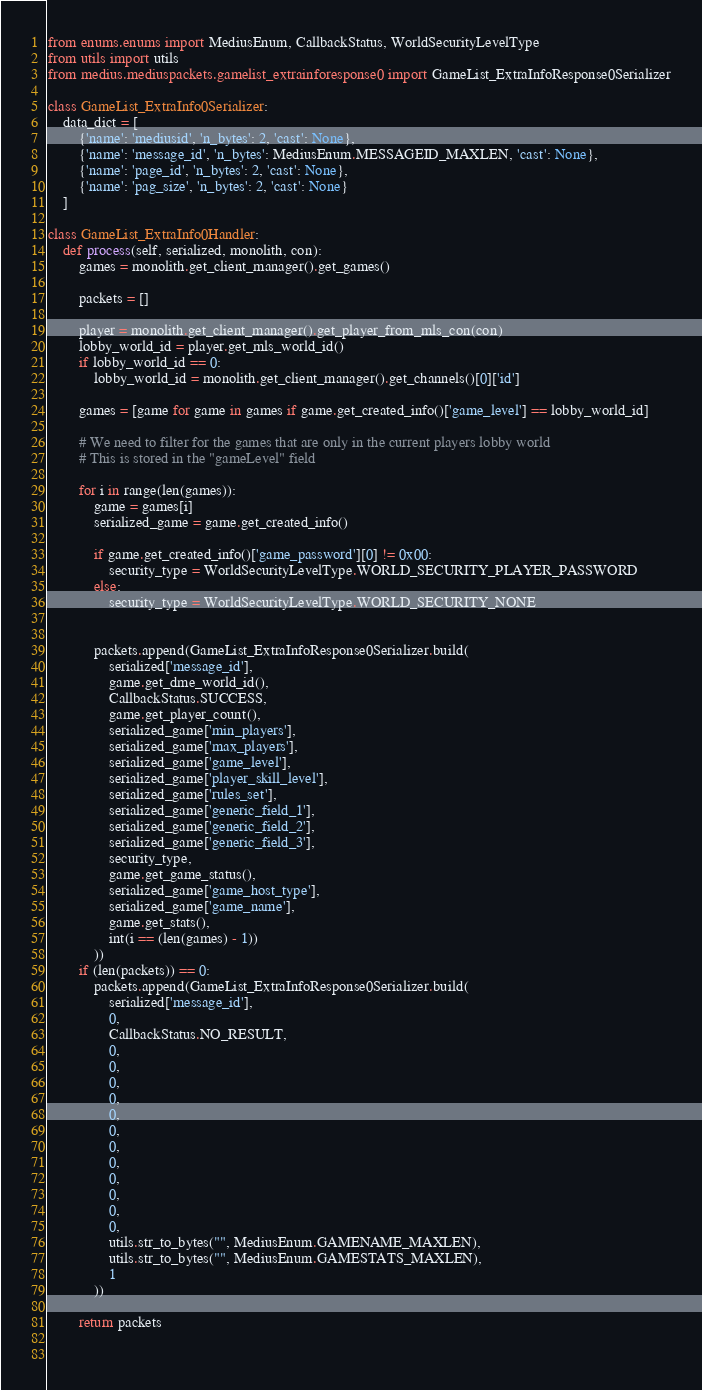Convert code to text. <code><loc_0><loc_0><loc_500><loc_500><_Python_>from enums.enums import MediusEnum, CallbackStatus, WorldSecurityLevelType
from utils import utils
from medius.mediuspackets.gamelist_extrainforesponse0 import GameList_ExtraInfoResponse0Serializer

class GameList_ExtraInfo0Serializer:
    data_dict = [
        {'name': 'mediusid', 'n_bytes': 2, 'cast': None},
        {'name': 'message_id', 'n_bytes': MediusEnum.MESSAGEID_MAXLEN, 'cast': None},
        {'name': 'page_id', 'n_bytes': 2, 'cast': None},
        {'name': 'pag_size', 'n_bytes': 2, 'cast': None}
    ]

class GameList_ExtraInfo0Handler:
    def process(self, serialized, monolith, con):
        games = monolith.get_client_manager().get_games()

        packets = []

        player = monolith.get_client_manager().get_player_from_mls_con(con)
        lobby_world_id = player.get_mls_world_id()
        if lobby_world_id == 0:
            lobby_world_id = monolith.get_client_manager().get_channels()[0]['id']

        games = [game for game in games if game.get_created_info()['game_level'] == lobby_world_id]

        # We need to filter for the games that are only in the current players lobby world
        # This is stored in the "gameLevel" field

        for i in range(len(games)):
            game = games[i]
            serialized_game = game.get_created_info()

            if game.get_created_info()['game_password'][0] != 0x00:
                security_type = WorldSecurityLevelType.WORLD_SECURITY_PLAYER_PASSWORD
            else:
                security_type = WorldSecurityLevelType.WORLD_SECURITY_NONE


            packets.append(GameList_ExtraInfoResponse0Serializer.build(
                serialized['message_id'],
                game.get_dme_world_id(),
                CallbackStatus.SUCCESS,
                game.get_player_count(),
                serialized_game['min_players'],
                serialized_game['max_players'],
                serialized_game['game_level'],
                serialized_game['player_skill_level'],
                serialized_game['rules_set'],
                serialized_game['generic_field_1'],
                serialized_game['generic_field_2'],
                serialized_game['generic_field_3'],
                security_type,
                game.get_game_status(),
                serialized_game['game_host_type'],
                serialized_game['game_name'],
                game.get_stats(),
                int(i == (len(games) - 1))
            ))
        if (len(packets)) == 0:
            packets.append(GameList_ExtraInfoResponse0Serializer.build(
                serialized['message_id'],
                0,
                CallbackStatus.NO_RESULT,
                0,
                0,
                0,
                0,
                0,
                0,
                0,
                0,
                0,
                0,
                0,
                0,
                utils.str_to_bytes("", MediusEnum.GAMENAME_MAXLEN),
                utils.str_to_bytes("", MediusEnum.GAMESTATS_MAXLEN),
                1
            ))

        return packets

        
</code> 